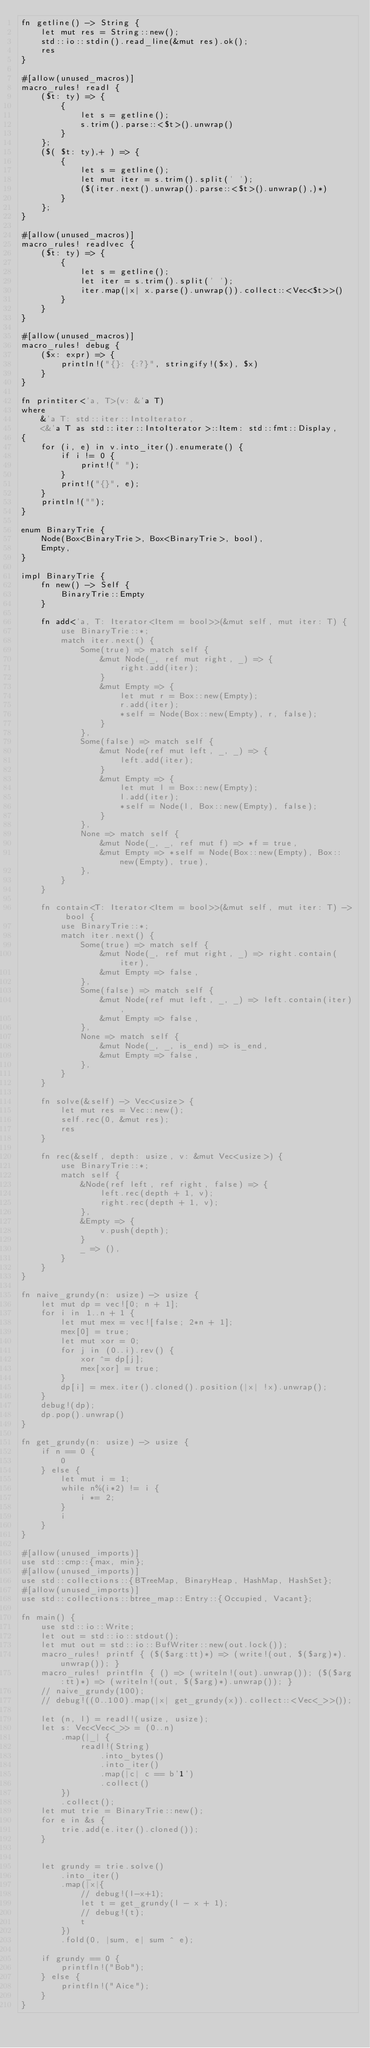Convert code to text. <code><loc_0><loc_0><loc_500><loc_500><_Rust_>fn getline() -> String {
    let mut res = String::new();
    std::io::stdin().read_line(&mut res).ok();
    res
}

#[allow(unused_macros)]
macro_rules! readl {
    ($t: ty) => {
        {
            let s = getline();
            s.trim().parse::<$t>().unwrap()
        }
    };
    ($( $t: ty),+ ) => {
        {
            let s = getline();
            let mut iter = s.trim().split(' ');
            ($(iter.next().unwrap().parse::<$t>().unwrap(),)*)
        }
    };
}

#[allow(unused_macros)]
macro_rules! readlvec {
    ($t: ty) => {
        {
            let s = getline();
            let iter = s.trim().split(' ');
            iter.map(|x| x.parse().unwrap()).collect::<Vec<$t>>()
        }
    }
}

#[allow(unused_macros)]
macro_rules! debug {
    ($x: expr) => {
        println!("{}: {:?}", stringify!($x), $x)
    }
}

fn printiter<'a, T>(v: &'a T)
where
    &'a T: std::iter::IntoIterator,
    <&'a T as std::iter::IntoIterator>::Item: std::fmt::Display,
{
    for (i, e) in v.into_iter().enumerate() {
        if i != 0 {
            print!(" ");
        }
        print!("{}", e);
    }
    println!("");
}

enum BinaryTrie {
    Node(Box<BinaryTrie>, Box<BinaryTrie>, bool),
    Empty,
}

impl BinaryTrie {
    fn new() -> Self {
        BinaryTrie::Empty
    }

    fn add<'a, T: Iterator<Item = bool>>(&mut self, mut iter: T) {
        use BinaryTrie::*;
        match iter.next() {
            Some(true) => match self {
                &mut Node(_, ref mut right, _) => {
                    right.add(iter);
                }
                &mut Empty => {
                    let mut r = Box::new(Empty);
                    r.add(iter);
                    *self = Node(Box::new(Empty), r, false);
                }
            },
            Some(false) => match self {
                &mut Node(ref mut left, _, _) => {
                    left.add(iter);
                }
                &mut Empty => {
                    let mut l = Box::new(Empty);
                    l.add(iter);
                    *self = Node(l, Box::new(Empty), false);
                }
            },
            None => match self {
                &mut Node(_, _, ref mut f) => *f = true,
                &mut Empty => *self = Node(Box::new(Empty), Box::new(Empty), true),
            },
        }
    }

    fn contain<T: Iterator<Item = bool>>(&mut self, mut iter: T) -> bool {
        use BinaryTrie::*;
        match iter.next() {
            Some(true) => match self {
                &mut Node(_, ref mut right, _) => right.contain(iter),
                &mut Empty => false,
            },
            Some(false) => match self {
                &mut Node(ref mut left, _, _) => left.contain(iter),
                &mut Empty => false,
            },
            None => match self {
                &mut Node(_, _, is_end) => is_end,
                &mut Empty => false,
            },
        }
    }

    fn solve(&self) -> Vec<usize> {
        let mut res = Vec::new();
        self.rec(0, &mut res);
        res
    }

    fn rec(&self, depth: usize, v: &mut Vec<usize>) {
        use BinaryTrie::*;
        match self {
            &Node(ref left, ref right, false) => {
                left.rec(depth + 1, v);
                right.rec(depth + 1, v);
            },
            &Empty => {
                v.push(depth);
            }
            _ => (),
        }
    }
}

fn naive_grundy(n: usize) -> usize {
    let mut dp = vec![0; n + 1];
    for i in 1..n + 1 {
        let mut mex = vec![false; 2*n + 1];
        mex[0] = true;
        let mut xor = 0;
        for j in (0..i).rev() {
            xor ^= dp[j];
            mex[xor] = true;
        }
        dp[i] = mex.iter().cloned().position(|x| !x).unwrap();
    }
    debug!(dp);
    dp.pop().unwrap()
}

fn get_grundy(n: usize) -> usize {
    if n == 0 {
        0
    } else {
        let mut i = 1;
        while n%(i*2) != i {
            i *= 2;
        }
        i
    }
}

#[allow(unused_imports)]
use std::cmp::{max, min};
#[allow(unused_imports)]
use std::collections::{BTreeMap, BinaryHeap, HashMap, HashSet};
#[allow(unused_imports)]
use std::collections::btree_map::Entry::{Occupied, Vacant};

fn main() {
    use std::io::Write;
    let out = std::io::stdout();
    let mut out = std::io::BufWriter::new(out.lock());
    macro_rules! printf { ($($arg:tt)*) => (write!(out, $($arg)*).unwrap()); }
    macro_rules! printfln { () => (writeln!(out).unwrap()); ($($arg:tt)*) => (writeln!(out, $($arg)*).unwrap()); }
    // naive_grundy(100);
    // debug!((0..100).map(|x| get_grundy(x)).collect::<Vec<_>>());

    let (n, l) = readl!(usize, usize);
    let s: Vec<Vec<_>> = (0..n)
        .map(|_| {
            readl!(String)
                .into_bytes()
                .into_iter()
                .map(|c| c == b'1')
                .collect()
        })
        .collect();
    let mut trie = BinaryTrie::new();
    for e in &s {
        trie.add(e.iter().cloned());
    }

    
    let grundy = trie.solve()
        .into_iter()
        .map(|x|{
            // debug!(l-x+1);
            let t = get_grundy(l - x + 1);
            // debug!(t);
            t
        })
        .fold(0, |sum, e| sum ^ e);

    if grundy == 0 {
        printfln!("Bob");
    } else {
        printfln!("Aice");
    }
}
</code> 